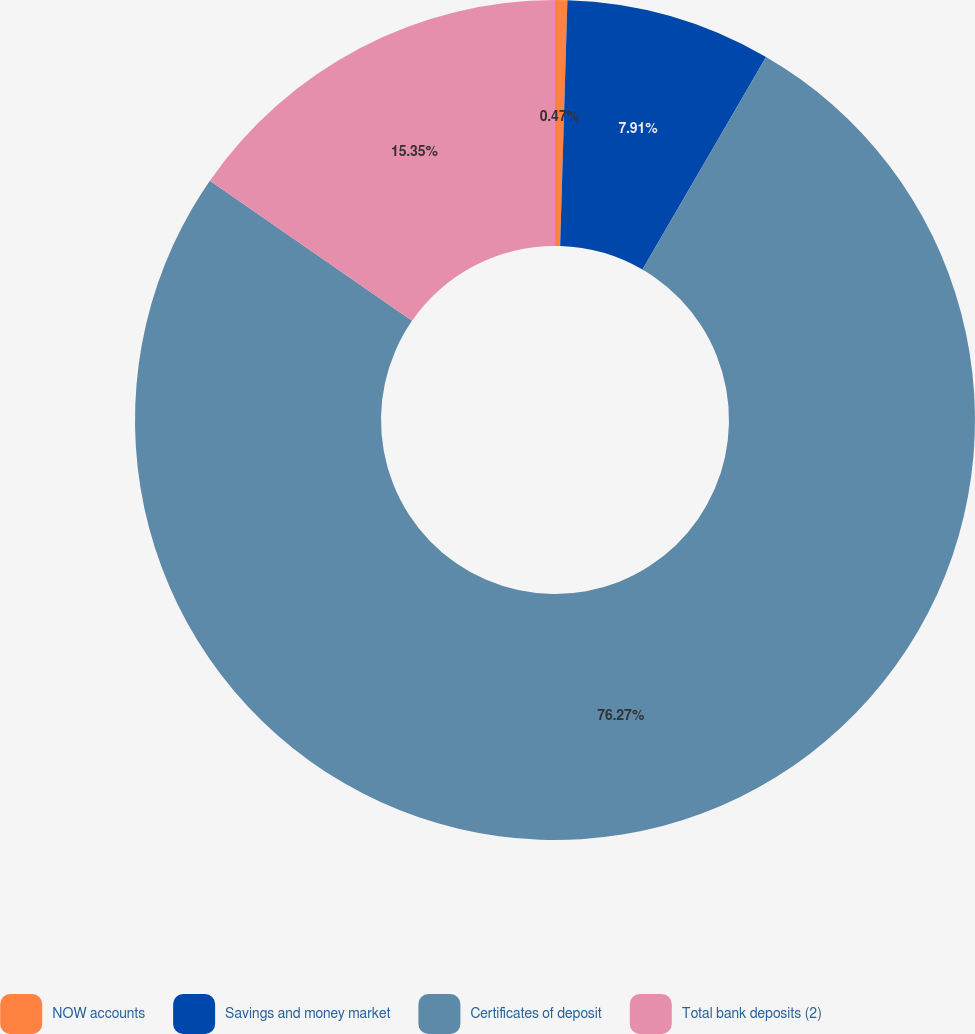Convert chart to OTSL. <chart><loc_0><loc_0><loc_500><loc_500><pie_chart><fcel>NOW accounts<fcel>Savings and money market<fcel>Certificates of deposit<fcel>Total bank deposits (2)<nl><fcel>0.47%<fcel>7.91%<fcel>76.28%<fcel>15.35%<nl></chart> 